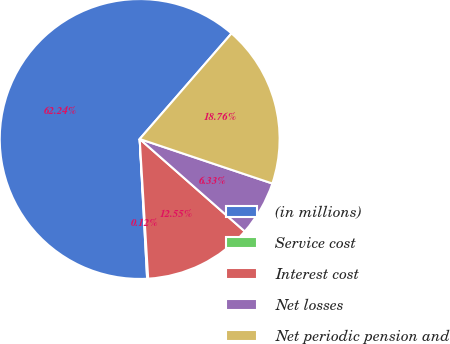Convert chart to OTSL. <chart><loc_0><loc_0><loc_500><loc_500><pie_chart><fcel>(in millions)<fcel>Service cost<fcel>Interest cost<fcel>Net losses<fcel>Net periodic pension and<nl><fcel>62.24%<fcel>0.12%<fcel>12.55%<fcel>6.33%<fcel>18.76%<nl></chart> 